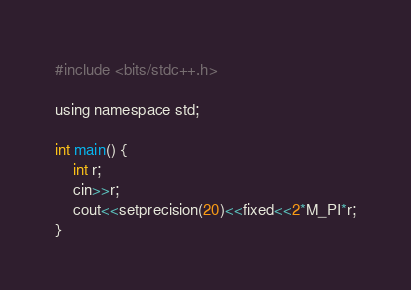Convert code to text. <code><loc_0><loc_0><loc_500><loc_500><_C_>#include <bits/stdc++.h>

using namespace std;

int main() {
    int r;
    cin>>r;
    cout<<setprecision(20)<<fixed<<2*M_PI*r;
}</code> 